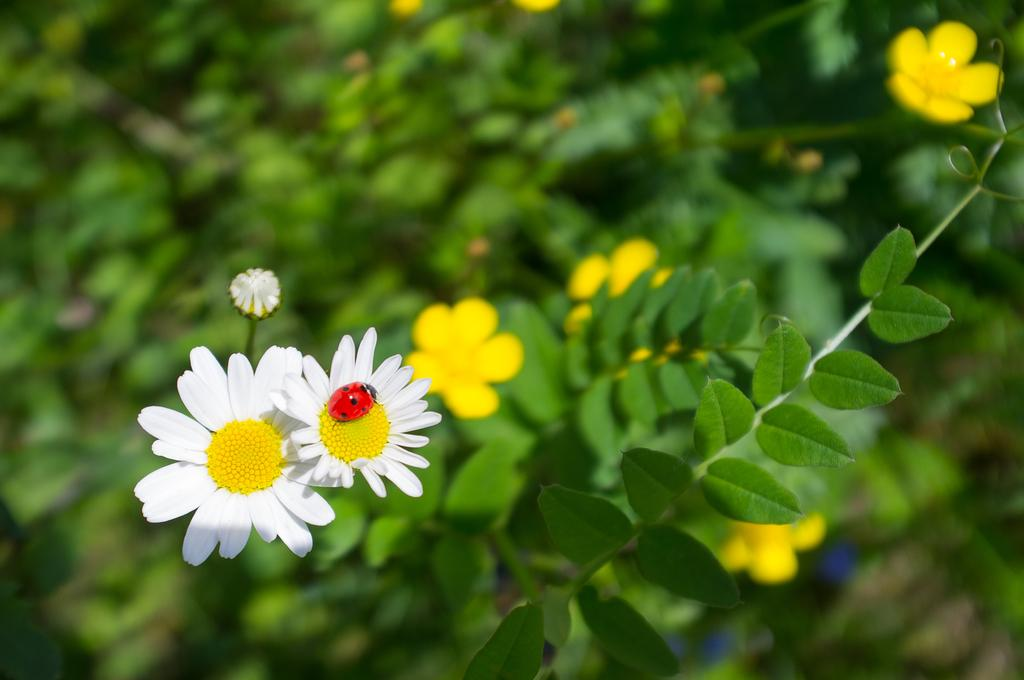What is present in the image? There is a plant in the image. What can be observed about the plant? The plant has flowers. Is there anything else notable on the plant? Yes, there is a bug on one of the flowers. What type of tin can be seen supporting the plant in the image? There is no tin present in the image, nor is there any support for the plant. 